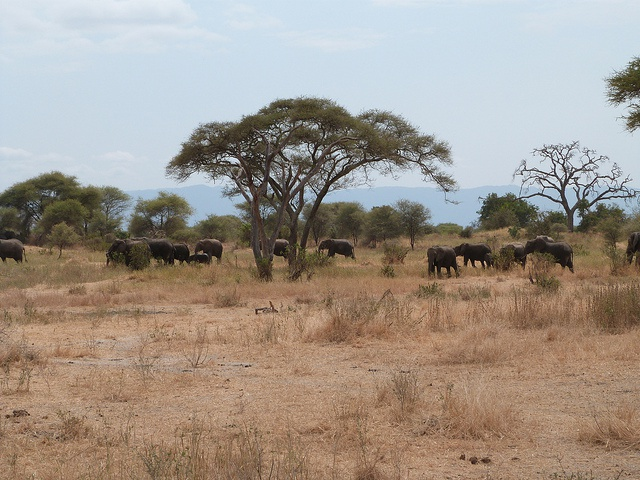Describe the objects in this image and their specific colors. I can see elephant in lightgray, black, and gray tones, elephant in lightgray, black, and gray tones, elephant in lightgray, black, gray, and maroon tones, elephant in lightgray, black, and gray tones, and elephant in lightgray, black, and gray tones in this image. 